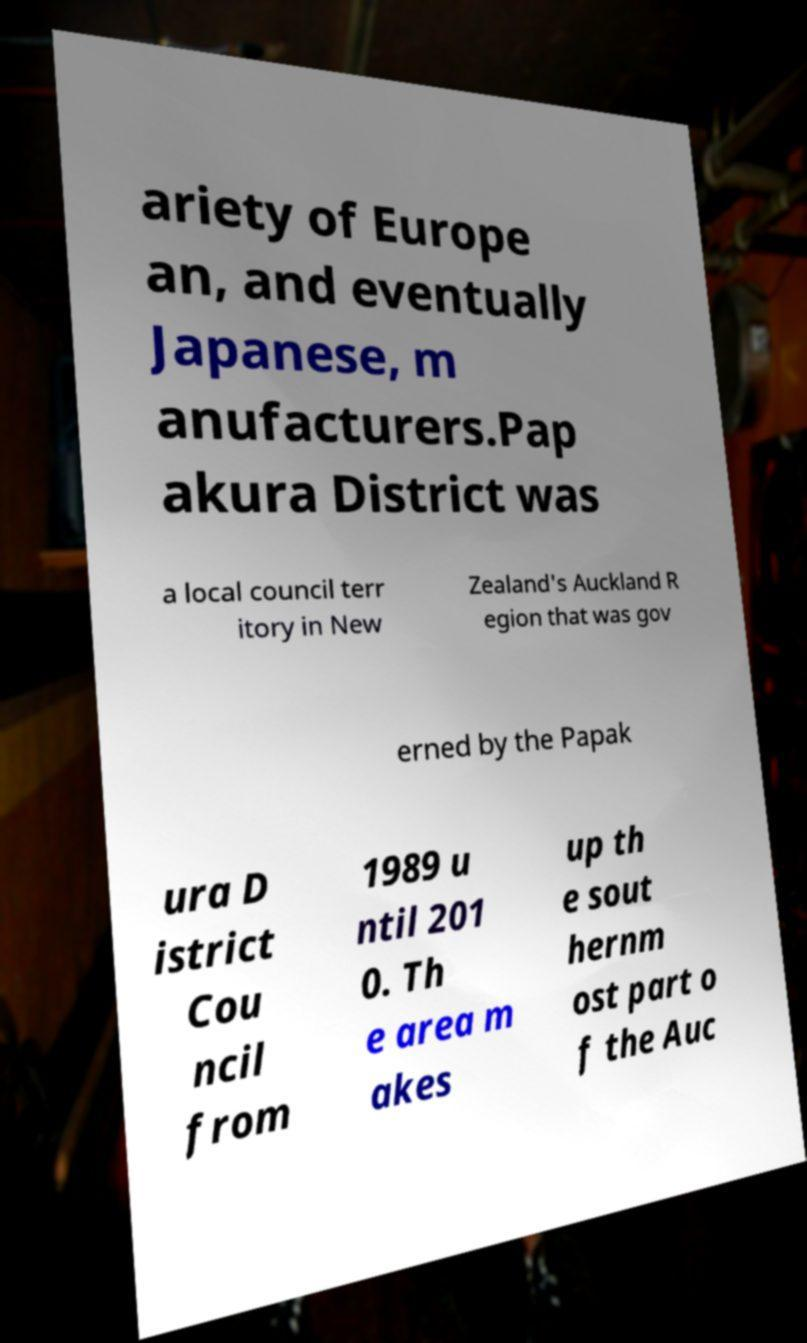Could you extract and type out the text from this image? ariety of Europe an, and eventually Japanese, m anufacturers.Pap akura District was a local council terr itory in New Zealand's Auckland R egion that was gov erned by the Papak ura D istrict Cou ncil from 1989 u ntil 201 0. Th e area m akes up th e sout hernm ost part o f the Auc 